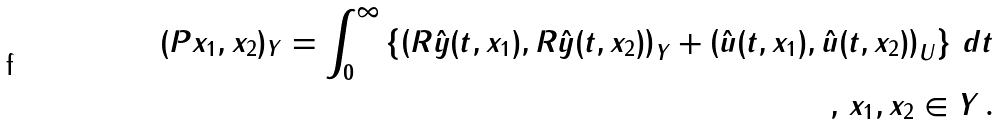Convert formula to latex. <formula><loc_0><loc_0><loc_500><loc_500>( P x _ { 1 } , x _ { 2 } ) _ { Y } = \int _ { 0 } ^ { \infty } \left \{ \left ( R \hat { y } ( t , x _ { 1 } ) , R \hat { y } ( t , x _ { 2 } ) \right ) _ { Y } + \left ( \hat { u } ( t , x _ { 1 } ) , \hat { u } ( t , x _ { 2 } ) \right ) _ { U } \right \} \, d t \\ , \, x _ { 1 } , x _ { 2 } \in Y \, .</formula> 